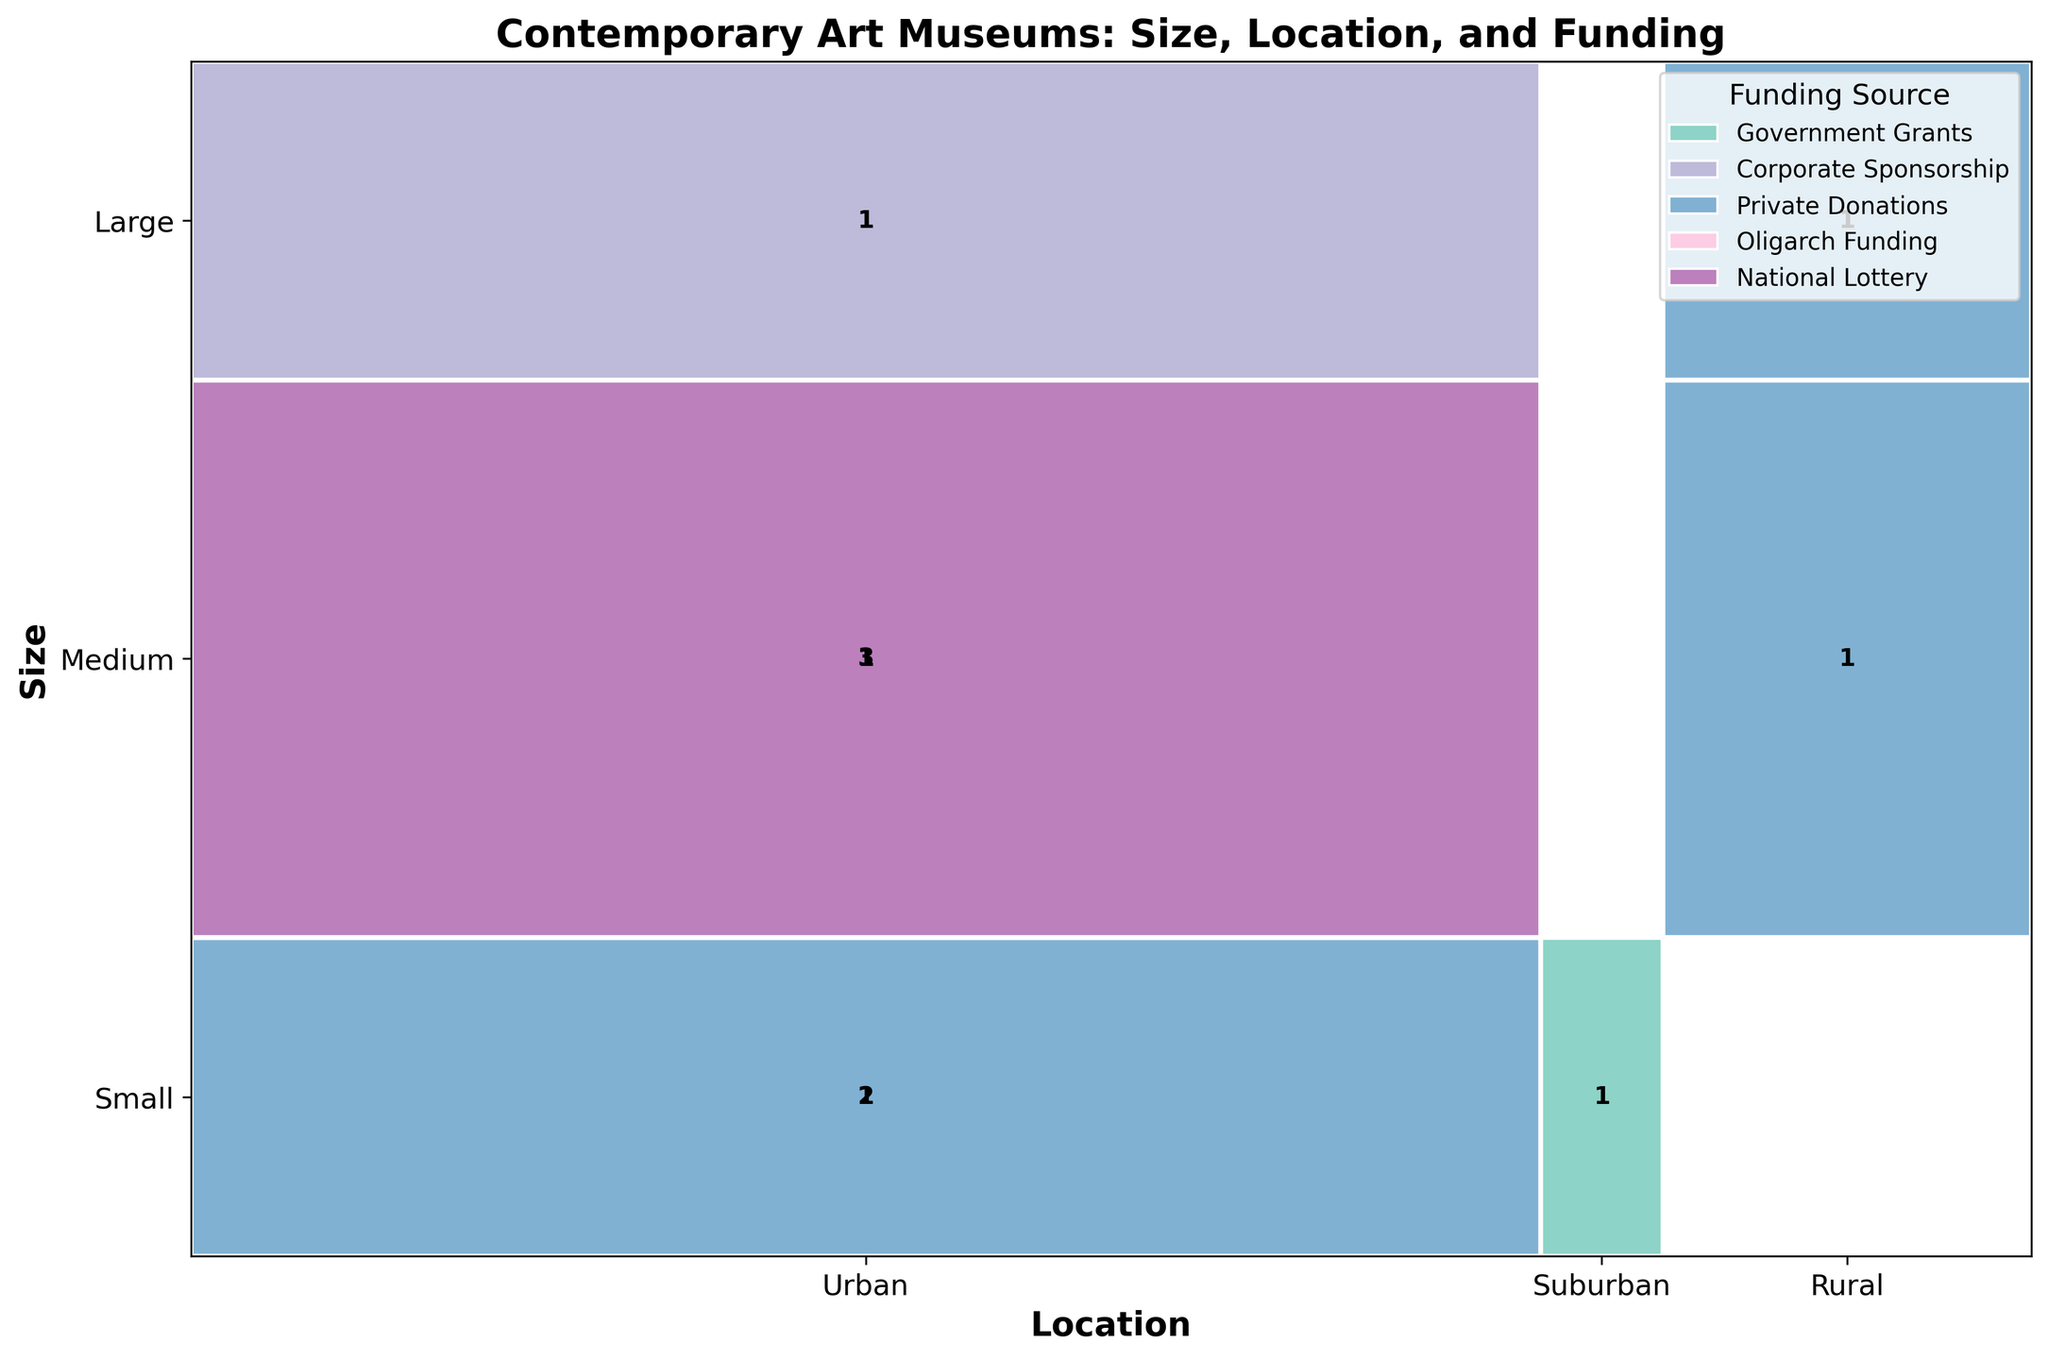What's the title of the figure? The title of the figure is at the top, indicating the content and focus of the visual representation. It reads: "Contemporary Art Museums: Size, Location, and Funding".
Answer: Contemporary Art Museums: Size, Location, and Funding What are the three institution sizes represented in the plot? The sizes of institutions are listed on the y-axis. They are: Small, Medium, and Large.
Answer: Small, Medium, Large How many 'Medium' institutions are funded by 'Government Grants'? Look at the Medium segment on the y-axis and find the rectangle colored for 'Government Grants'. The count inside this segment (three) indicates the number of such institutions.
Answer: 3 Compare the number of 'Urban' museums funded by 'Private Donations' to those funded by 'Government Grants'. Find the 'Urban' segment along the x-axis. Count the rectangles for 'Private Donations' and 'Government Grants' within this segment. 'Private Donations' has 2, while 'Government Grants' has 3.
Answer: Private Donations: 2, Government Grants: 3 Which funding source is used by most 'Large' institutions? In the 'Large' segment on the y-axis, observe the different funding sources and their respective counts. 'Corporate Sponsorship' and 'Private Donations' each fund 1 institution, while 'Government Grants' also funds 1. This indicates there’s no dominating source.
Answer: No dominant source Are there any 'Suburban' museums funded by 'Private Donations'? Look at the 'Suburban' segment along the x-axis and check for any rectangles that correspond to 'Private Donations'. There are none, so there are no 'Suburban' museums funded by 'Private Donations'.
Answer: No Which geographic location has the highest variety of funding sources? Count the different funding sources in each location segment ('Urban', 'Suburban', 'Rural') on the x-axis. 'Urban' has the most variety, with Government Grants, Corporate Sponsorship, Private Donations, Oligarch Funding, and National Lottery.
Answer: Urban How many 'Large' institutions are there in total? Add up all genres of funding for 'Large' institutions by summing the counts in the 'Large' segment on the y-axis. There are four such rectangles indicating a total count of 4.
Answer: 4 Which funding source is least used among 'Medium' institutions? In the 'Medium' segment along the y-axis, check the counts for each funding source. The one with the lowest count is 'Oligarch Funding' with only 1 institution.
Answer: Oligarch Funding 